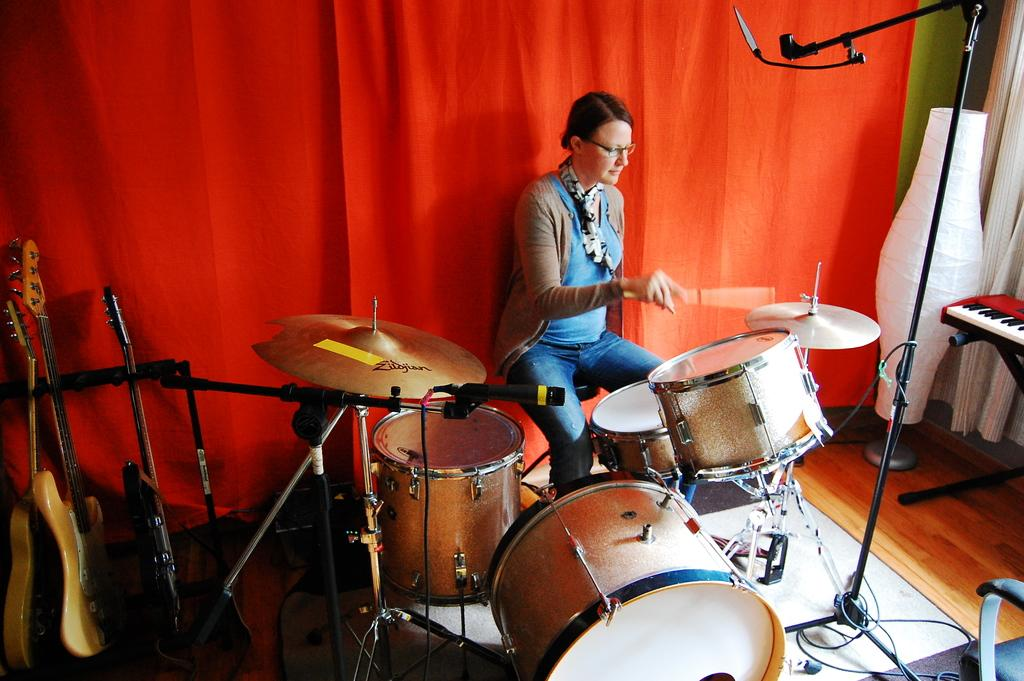What is the person in the image doing? The person is sitting on a chair and playing a musical drum. What accessories is the person wearing? The person is wearing a spectacle and a scarf. What can be seen in the background of the image? There is a red color curtain and a stand visible in the background. Are there any other musical instruments in the image? Yes, there are musical drums visible in the background. Can you see a snail crawling on the musical drum in the image? No, there is no snail present in the image. 